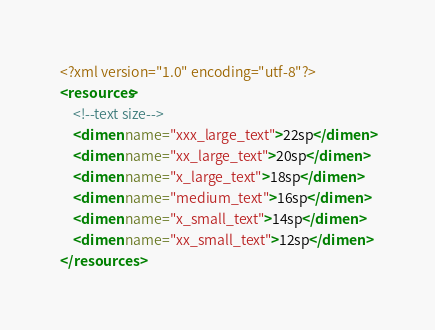<code> <loc_0><loc_0><loc_500><loc_500><_XML_><?xml version="1.0" encoding="utf-8"?>
<resources>
    <!--text size-->
    <dimen name="xxx_large_text">22sp</dimen>
    <dimen name="xx_large_text">20sp</dimen>
    <dimen name="x_large_text">18sp</dimen>
    <dimen name="medium_text">16sp</dimen>
    <dimen name="x_small_text">14sp</dimen>
    <dimen name="xx_small_text">12sp</dimen>
</resources></code> 